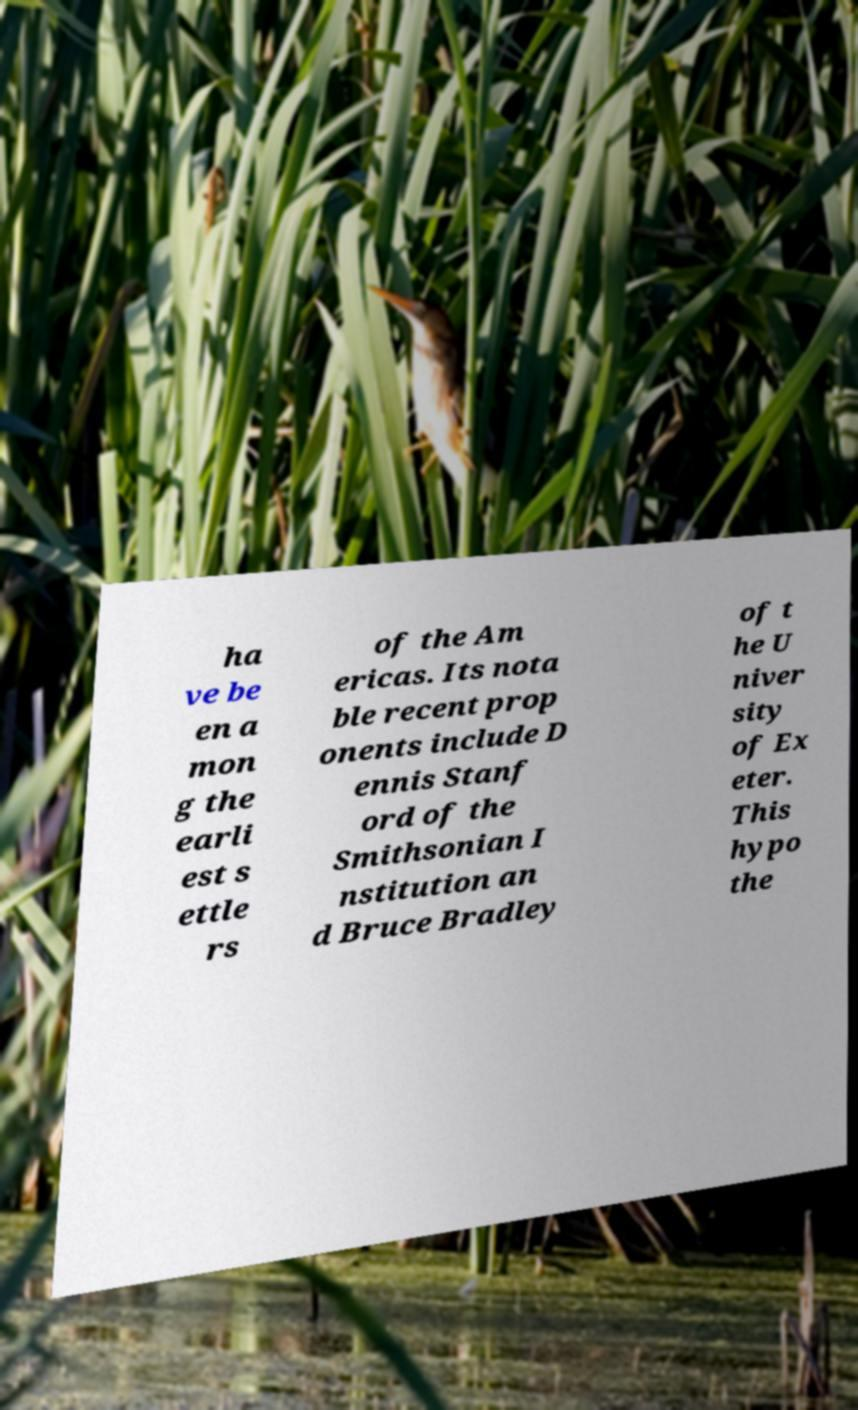Please read and relay the text visible in this image. What does it say? ha ve be en a mon g the earli est s ettle rs of the Am ericas. Its nota ble recent prop onents include D ennis Stanf ord of the Smithsonian I nstitution an d Bruce Bradley of t he U niver sity of Ex eter. This hypo the 